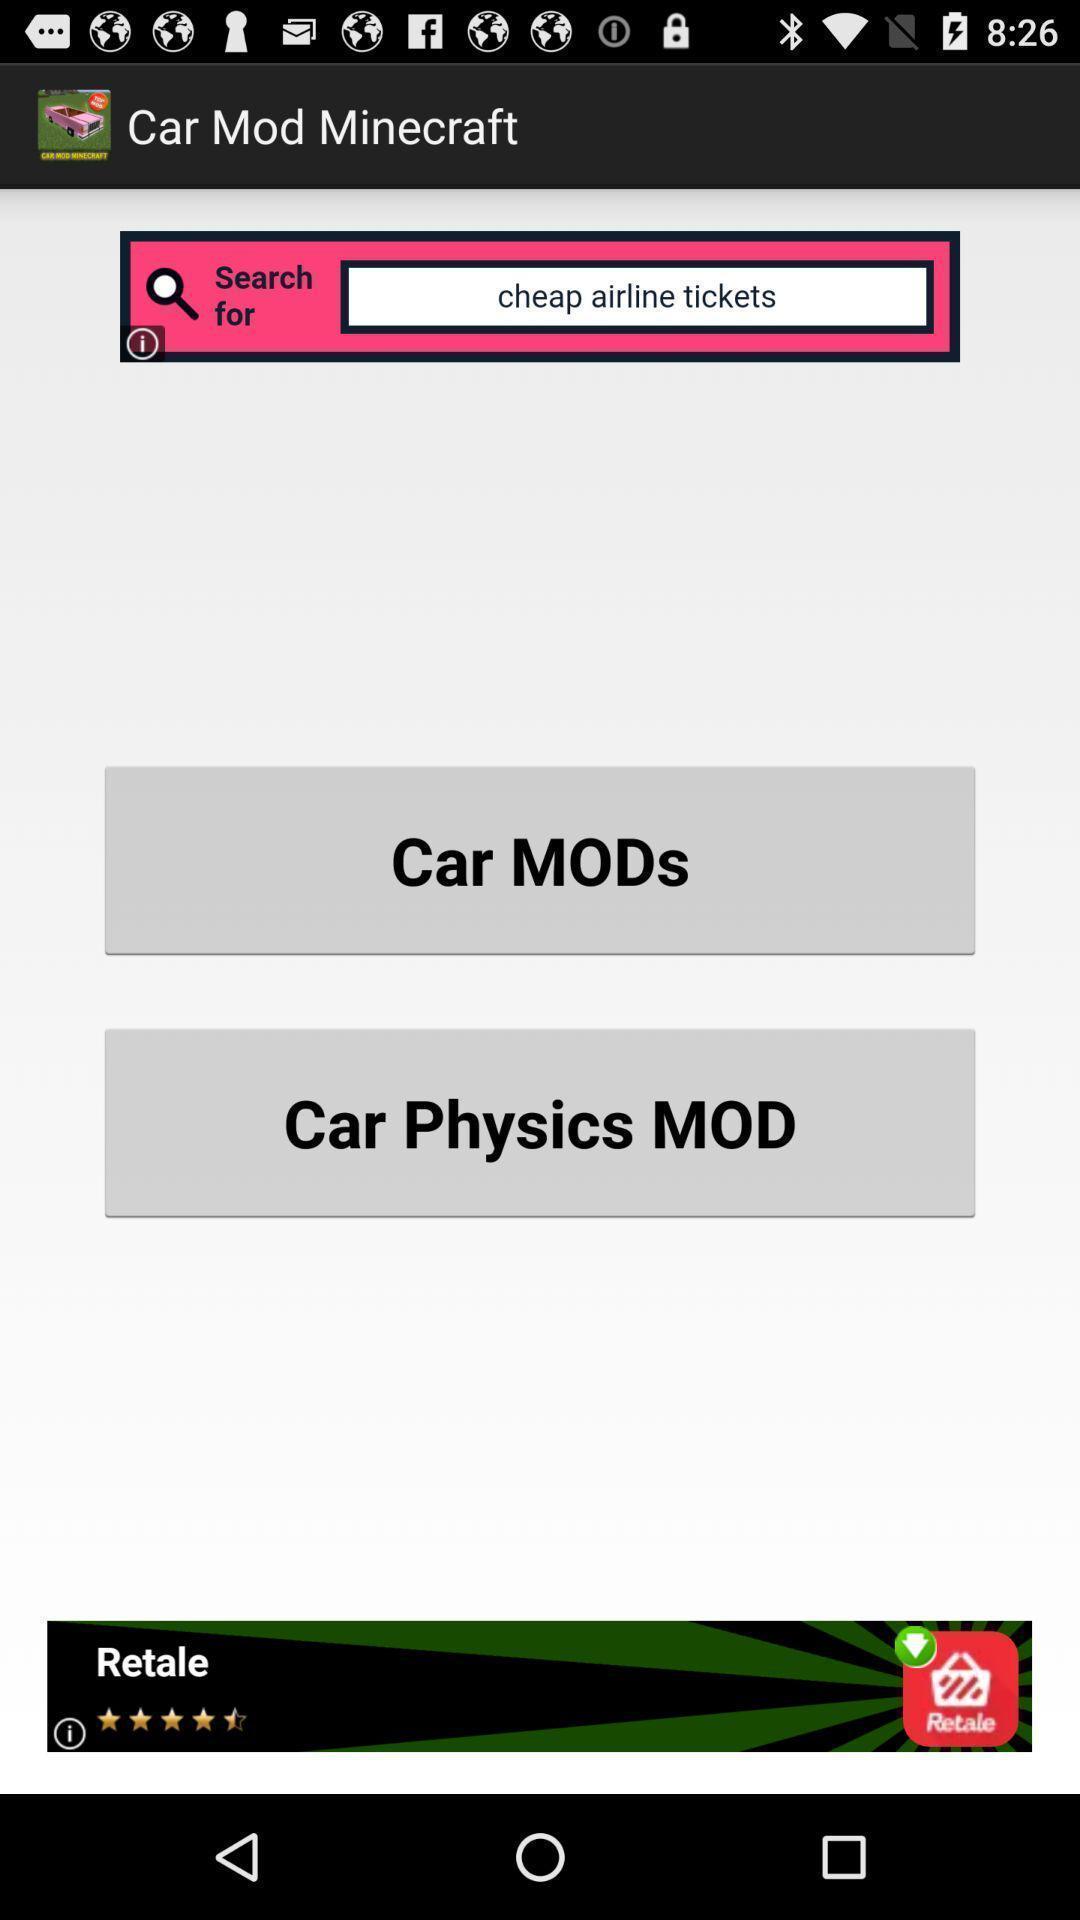What details can you identify in this image? Social app for car mod minecraft. 